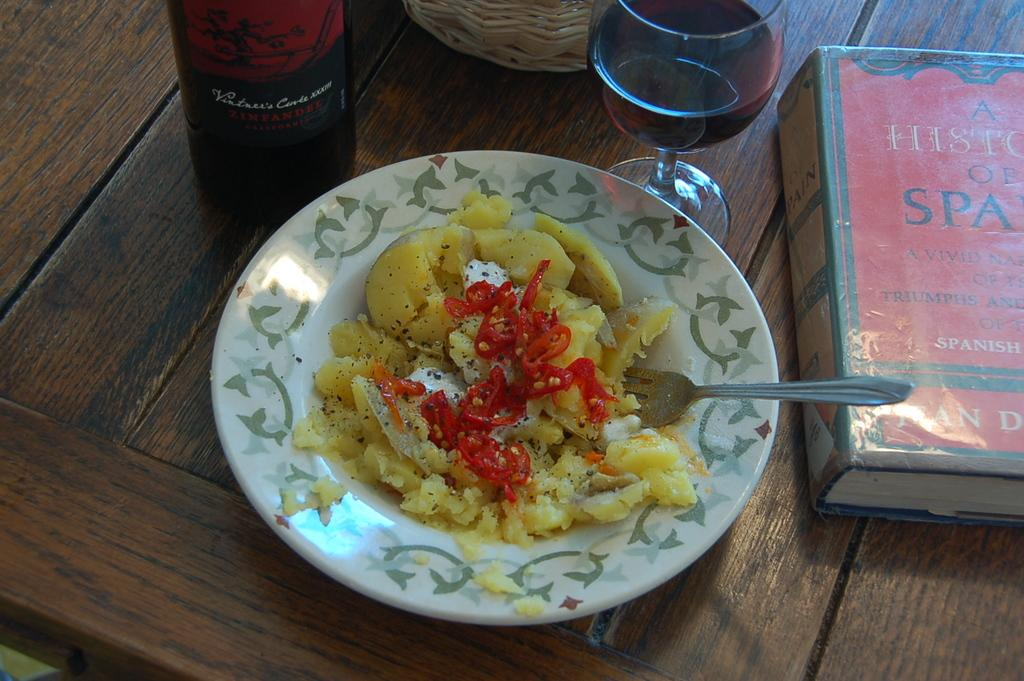What piece of furniture is present in the image? There is a table in the image. What objects can be seen on the table? There is a bottle, a glass, a book, and a plate with food on the table. Is there any utensil visible in the image? Yes, there is a fork in the middle of the image. What type of wine is being served in the glass in the image? There is no glass of wine present in the image; it features a glass with an unspecified beverage. Can you tell me the weight of the pan on the table in the image? There is no pan present in the image; it features a table with a bottle, a glass, a book, a plate with food, and a fork. 